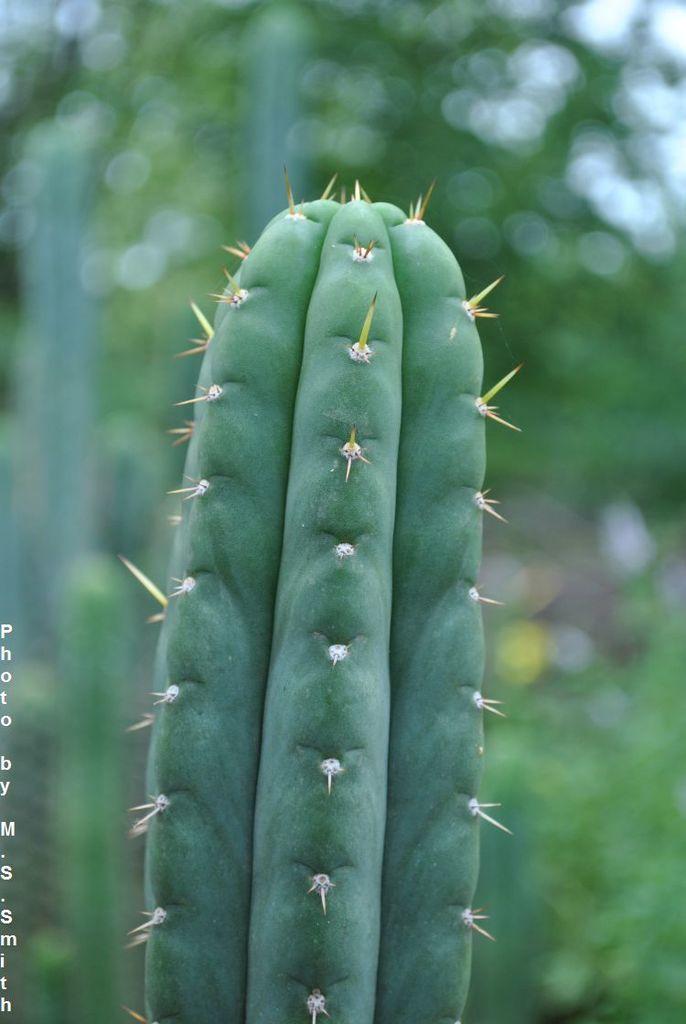Could you give a brief overview of what you see in this image? In this image we can see a cactus plant. In the background it is blur. On the left side there is text. 